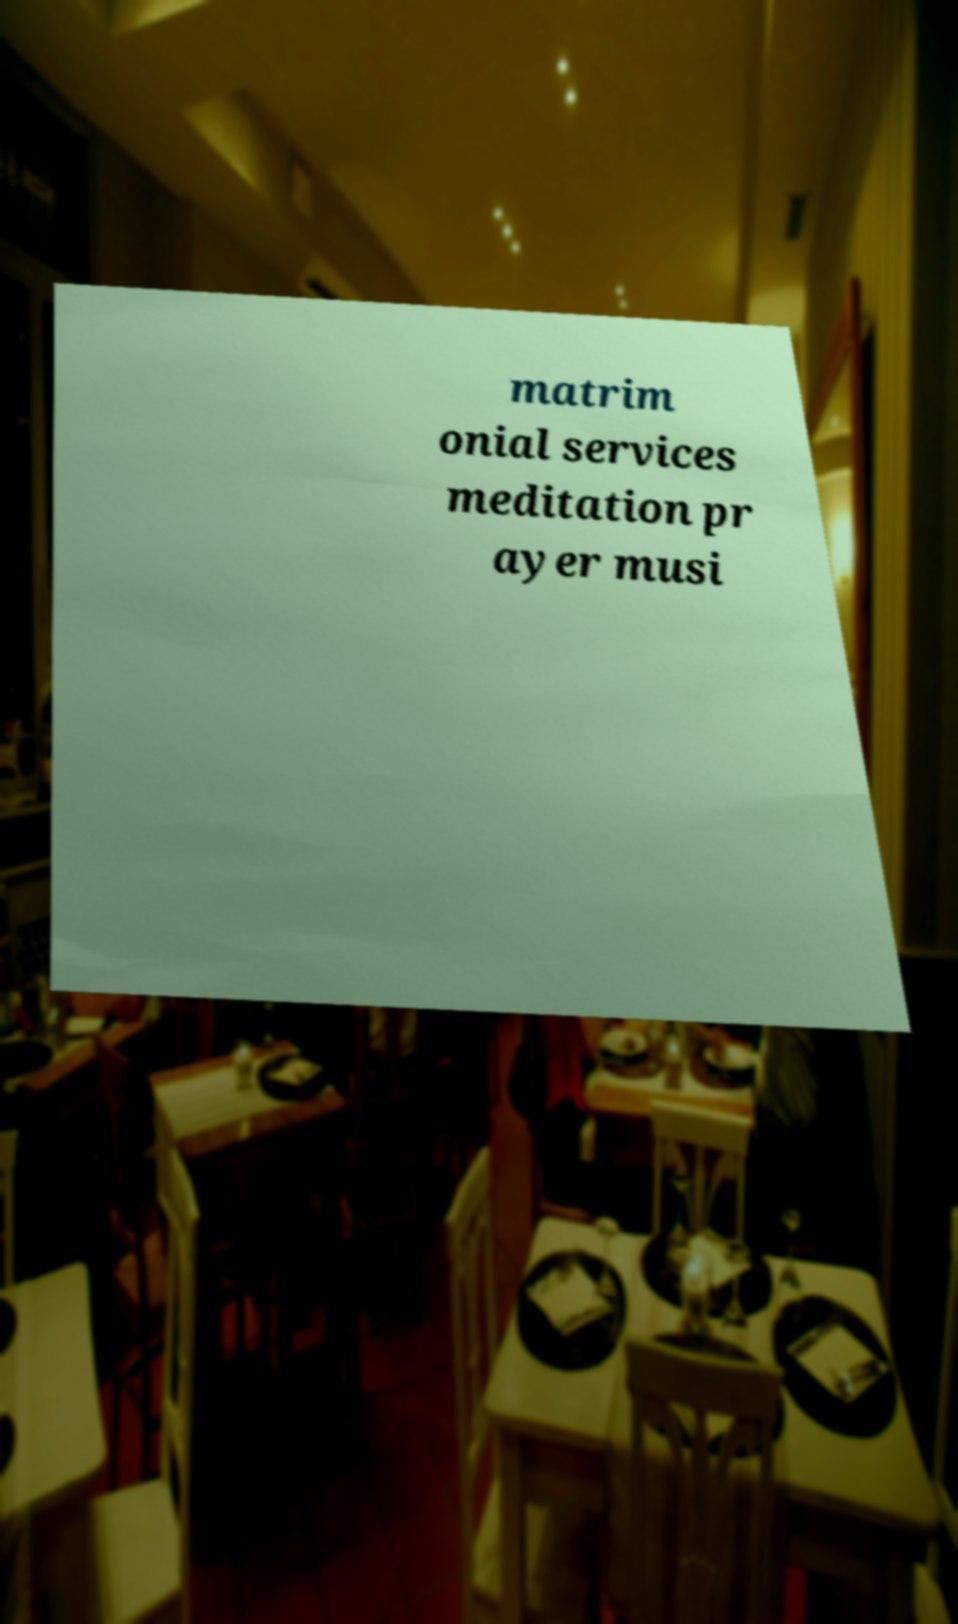Please read and relay the text visible in this image. What does it say? matrim onial services meditation pr ayer musi 